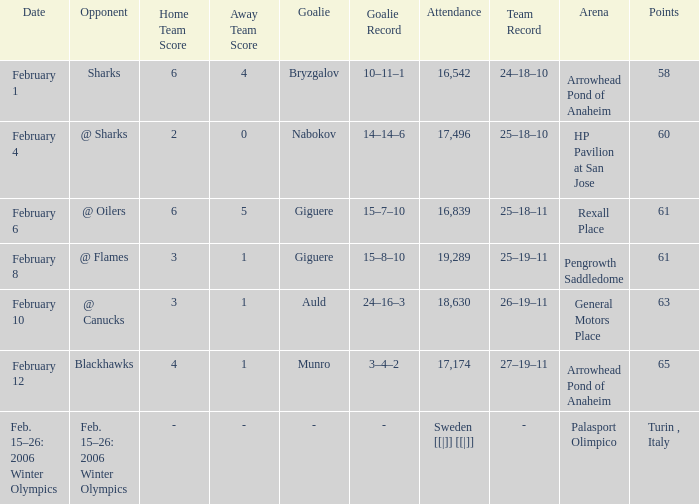What is the result when the score was 2-0? 25–18–10. 